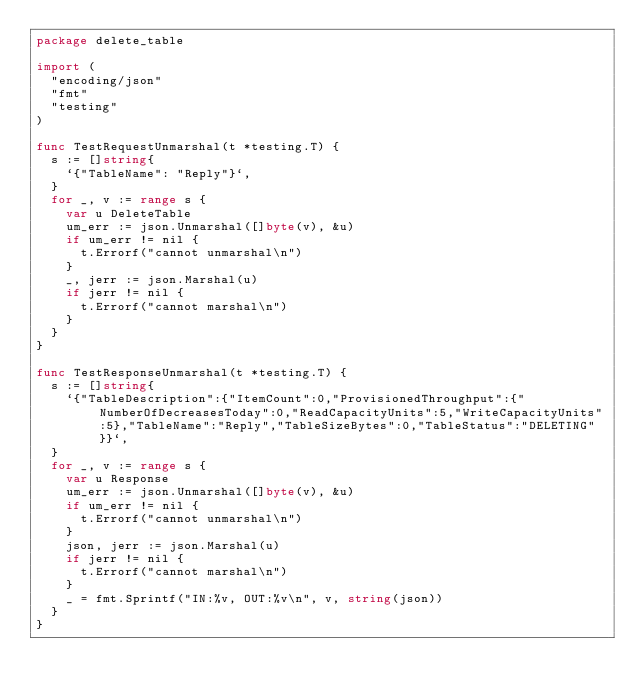<code> <loc_0><loc_0><loc_500><loc_500><_Go_>package delete_table

import (
	"encoding/json"
	"fmt"
	"testing"
)

func TestRequestUnmarshal(t *testing.T) {
	s := []string{
		`{"TableName": "Reply"}`,
	}
	for _, v := range s {
		var u DeleteTable
		um_err := json.Unmarshal([]byte(v), &u)
		if um_err != nil {
			t.Errorf("cannot unmarshal\n")
		}
		_, jerr := json.Marshal(u)
		if jerr != nil {
			t.Errorf("cannot marshal\n")
		}
	}
}

func TestResponseUnmarshal(t *testing.T) {
	s := []string{
		`{"TableDescription":{"ItemCount":0,"ProvisionedThroughput":{"NumberOfDecreasesToday":0,"ReadCapacityUnits":5,"WriteCapacityUnits":5},"TableName":"Reply","TableSizeBytes":0,"TableStatus":"DELETING"}}`,
	}
	for _, v := range s {
		var u Response
		um_err := json.Unmarshal([]byte(v), &u)
		if um_err != nil {
			t.Errorf("cannot unmarshal\n")
		}
		json, jerr := json.Marshal(u)
		if jerr != nil {
			t.Errorf("cannot marshal\n")
		}
		_ = fmt.Sprintf("IN:%v, OUT:%v\n", v, string(json))
	}
}
</code> 